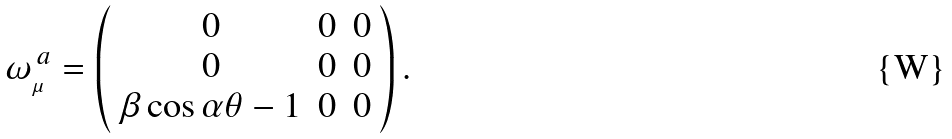<formula> <loc_0><loc_0><loc_500><loc_500>\omega _ { _ { \mu } } ^ { \, a } = \left ( \begin{array} { c c c } 0 & 0 & 0 \\ 0 & 0 & 0 \\ \beta \cos \alpha \theta - 1 & 0 & 0 \end{array} \right ) .</formula> 